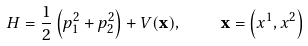<formula> <loc_0><loc_0><loc_500><loc_500>H = \frac { 1 } { 2 } \left ( p _ { 1 } ^ { 2 } + p _ { 2 } ^ { 2 } \right ) + V ( { \mathbf x } ) , \quad { \mathbf x } = \left ( x ^ { 1 } , x ^ { 2 } \right )</formula> 